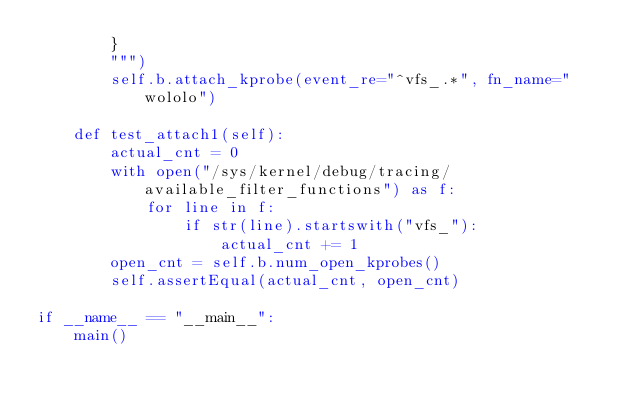Convert code to text. <code><loc_0><loc_0><loc_500><loc_500><_Python_>        }
        """)
        self.b.attach_kprobe(event_re="^vfs_.*", fn_name="wololo")

    def test_attach1(self):
        actual_cnt = 0
        with open("/sys/kernel/debug/tracing/available_filter_functions") as f:
            for line in f:
                if str(line).startswith("vfs_"):
                    actual_cnt += 1
        open_cnt = self.b.num_open_kprobes()
        self.assertEqual(actual_cnt, open_cnt)

if __name__ == "__main__":
    main()
</code> 